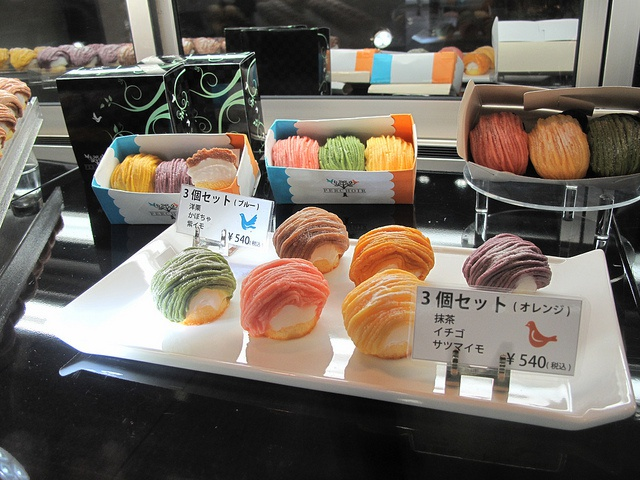Describe the objects in this image and their specific colors. I can see cake in black, salmon, and brown tones, cake in black, red, and tan tones, cake in black, gray, olive, darkgray, and beige tones, cake in black, brown, gray, and maroon tones, and cake in black, brown, and tan tones in this image. 